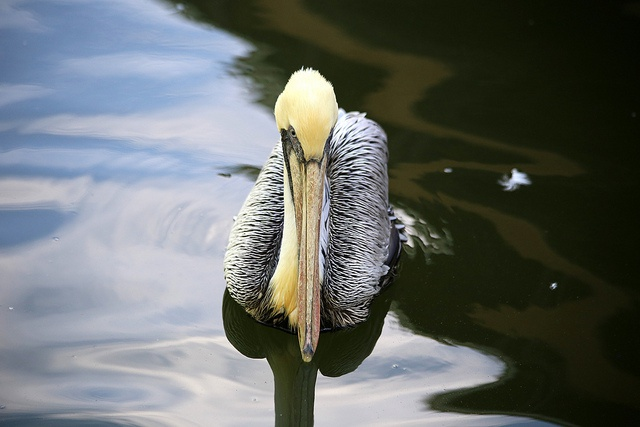Describe the objects in this image and their specific colors. I can see a bird in gray, lightgray, black, and darkgray tones in this image. 